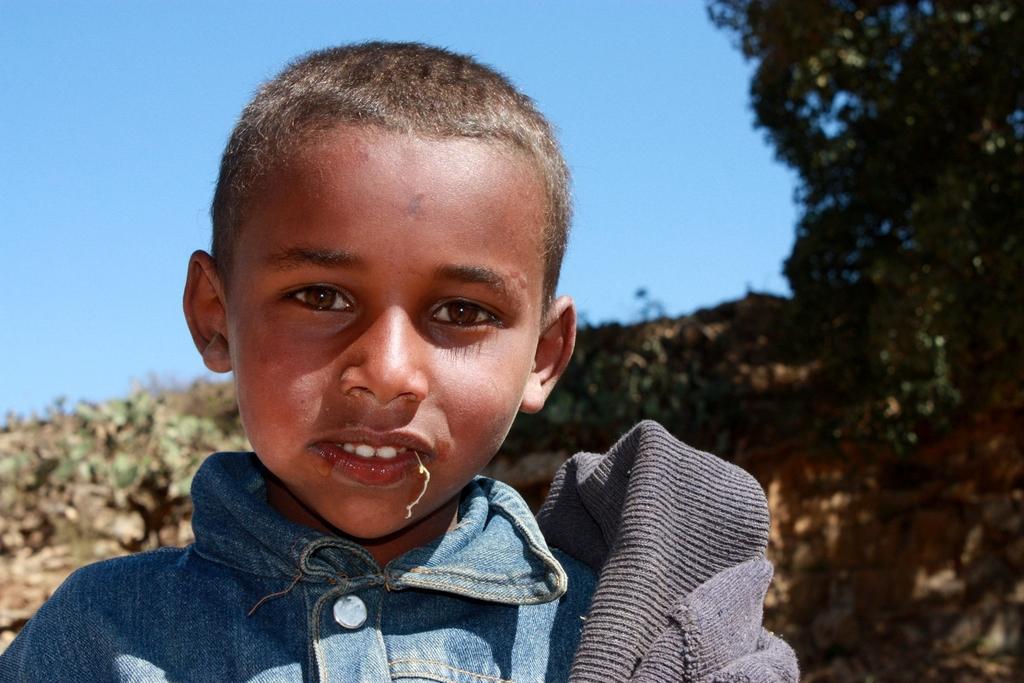How would you summarize this image in a sentence or two? In this image we can see a kid and behind him we can see trees and sky. 